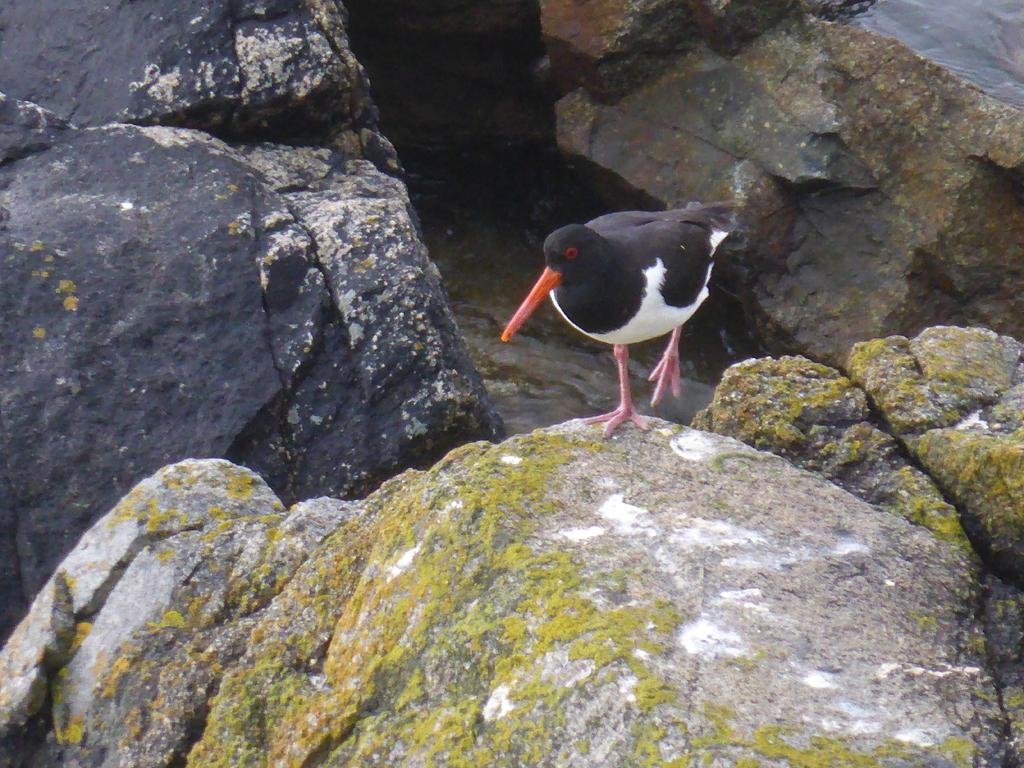What type of animal can be seen in the image? There is a bird in the image. What is the bird standing on? The bird is standing on a rock. What other geological features are present in the image? There are other rock hills in the image. What organization does the bird belong to in the image? There is no indication in the image that the bird belongs to any organization. 